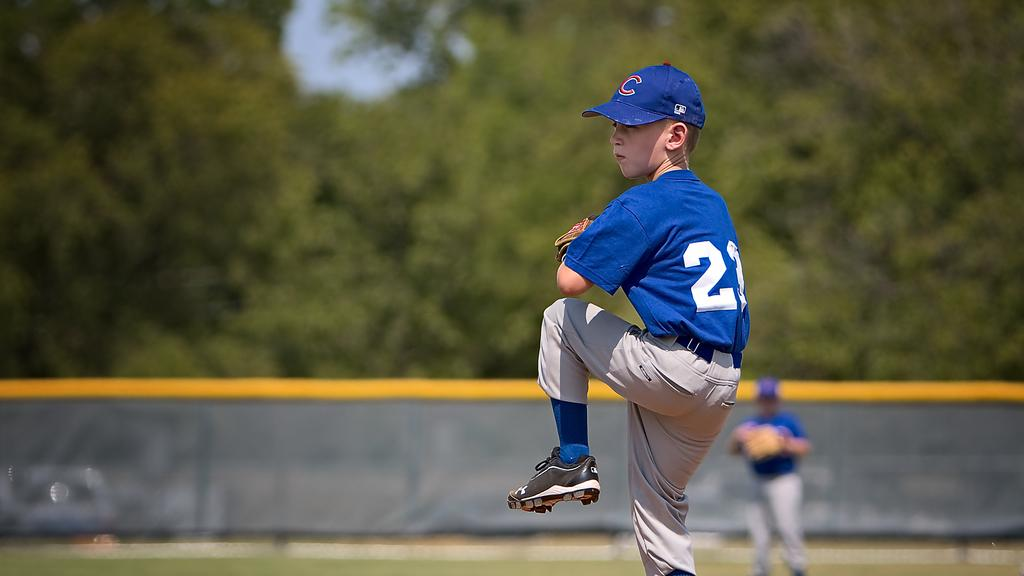Provide a one-sentence caption for the provided image. Player 23 was in the midst of throwing a pitch at the baseball game. 